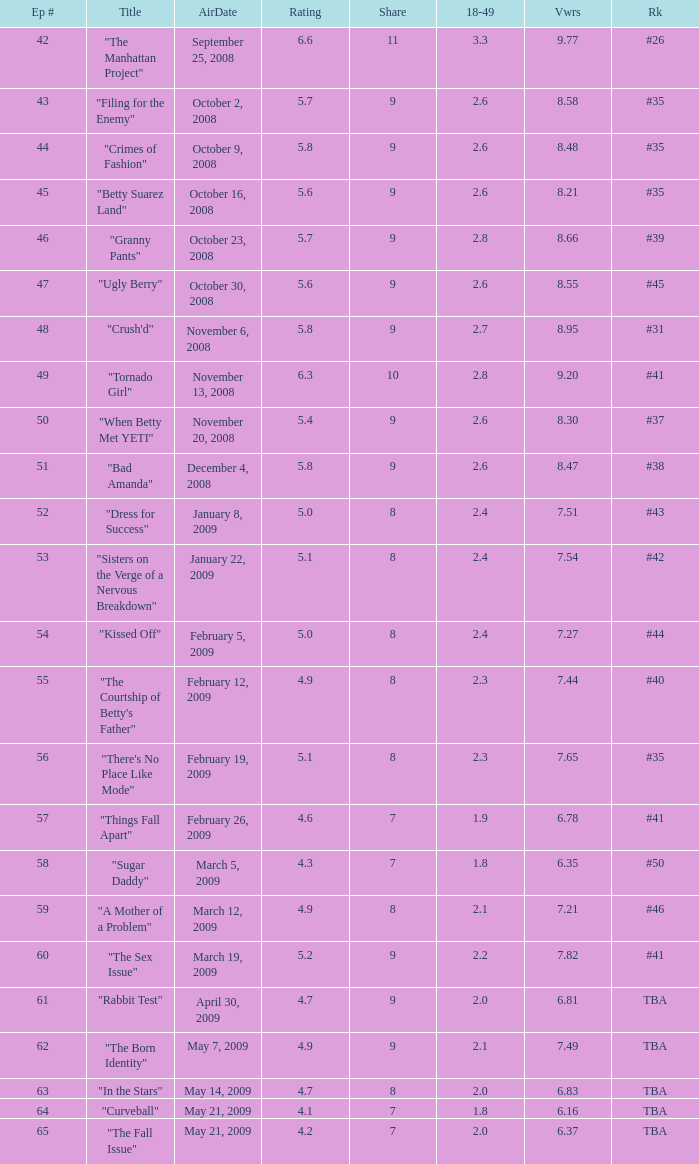What is the total number of Viewers when the rank is #40? 1.0. 